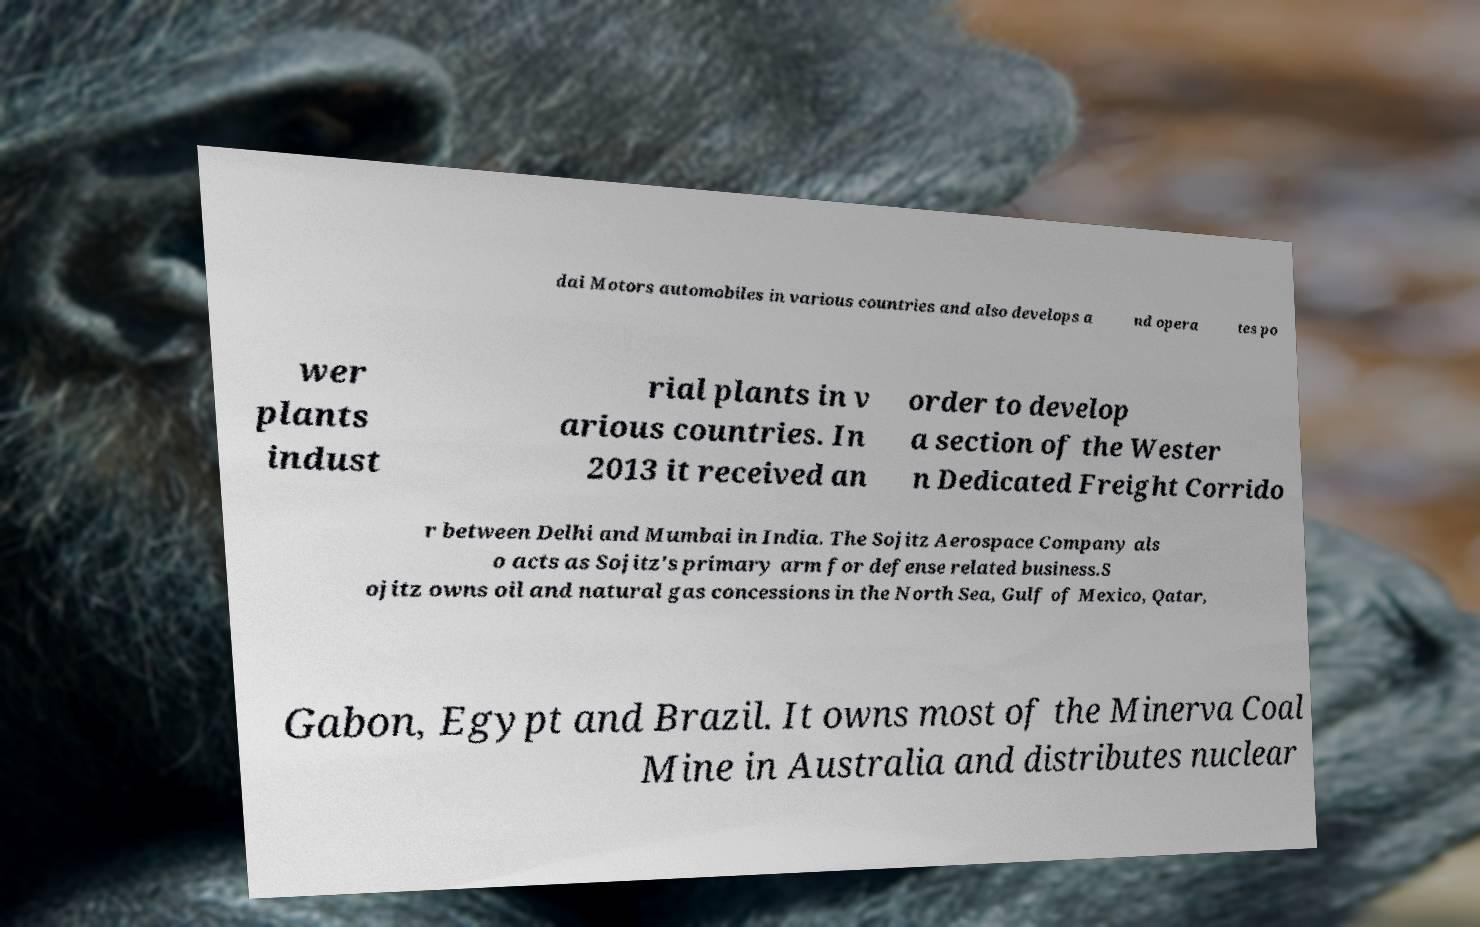There's text embedded in this image that I need extracted. Can you transcribe it verbatim? dai Motors automobiles in various countries and also develops a nd opera tes po wer plants indust rial plants in v arious countries. In 2013 it received an order to develop a section of the Wester n Dedicated Freight Corrido r between Delhi and Mumbai in India. The Sojitz Aerospace Company als o acts as Sojitz's primary arm for defense related business.S ojitz owns oil and natural gas concessions in the North Sea, Gulf of Mexico, Qatar, Gabon, Egypt and Brazil. It owns most of the Minerva Coal Mine in Australia and distributes nuclear 